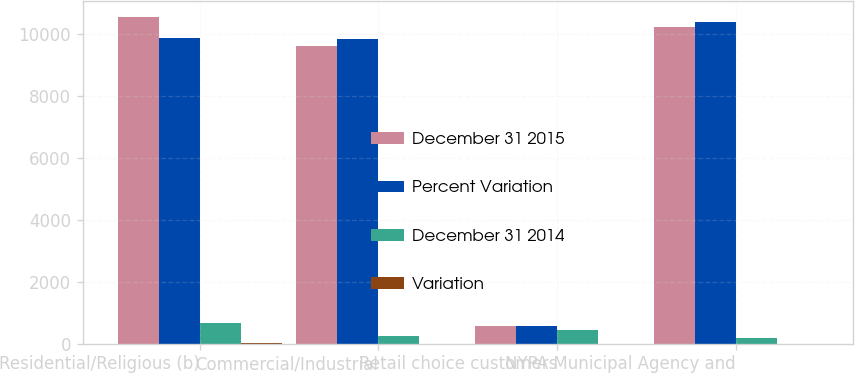<chart> <loc_0><loc_0><loc_500><loc_500><stacked_bar_chart><ecel><fcel>Residential/Religious (b)<fcel>Commercial/Industrial<fcel>Retail choice customers<fcel>NYPA Municipal Agency and<nl><fcel>December 31 2015<fcel>10543<fcel>9602<fcel>558<fcel>10208<nl><fcel>Percent Variation<fcel>9868<fcel>9834<fcel>558<fcel>10380<nl><fcel>December 31 2014<fcel>675<fcel>232<fcel>441<fcel>172<nl><fcel>Variation<fcel>6.8<fcel>2.4<fcel>1.7<fcel>1.7<nl></chart> 